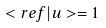Convert formula to latex. <formula><loc_0><loc_0><loc_500><loc_500>< r e f | u > = 1</formula> 